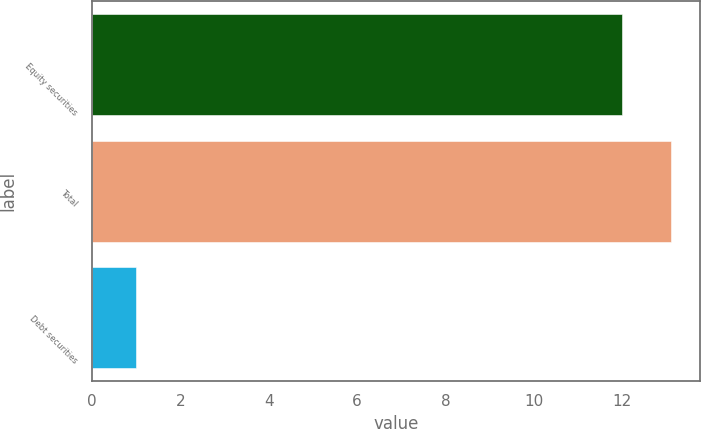Convert chart to OTSL. <chart><loc_0><loc_0><loc_500><loc_500><bar_chart><fcel>Equity securities<fcel>Total<fcel>Debt securities<nl><fcel>12<fcel>13.1<fcel>1<nl></chart> 